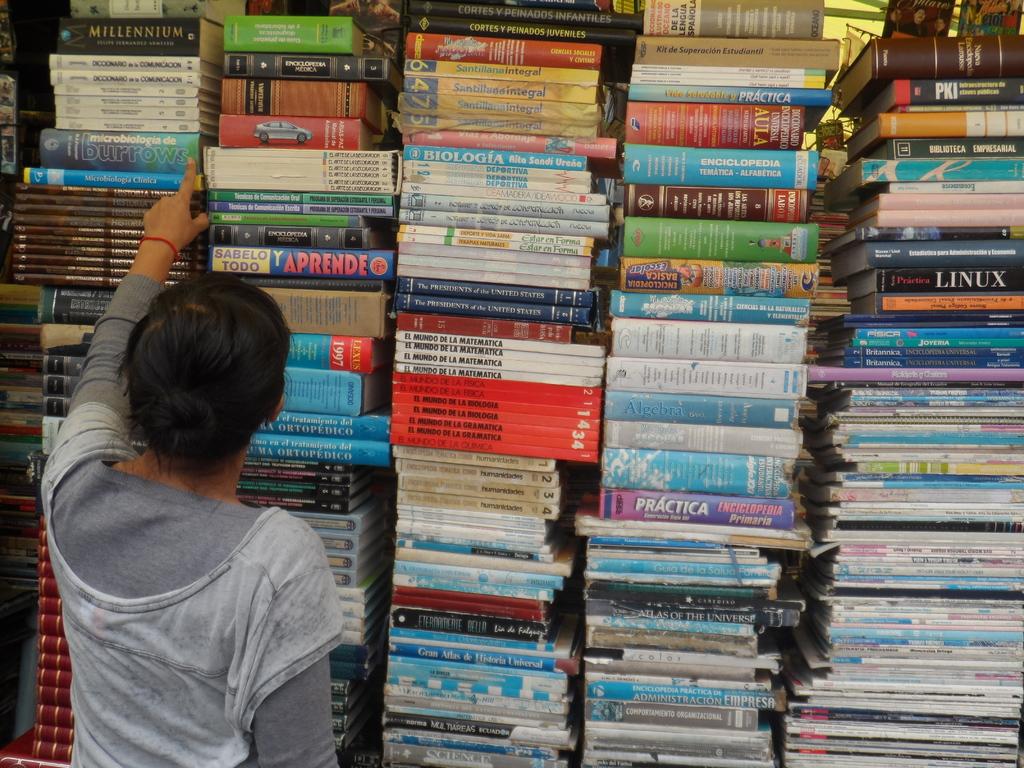What color is the linux book on the right?
Offer a very short reply. Black. 